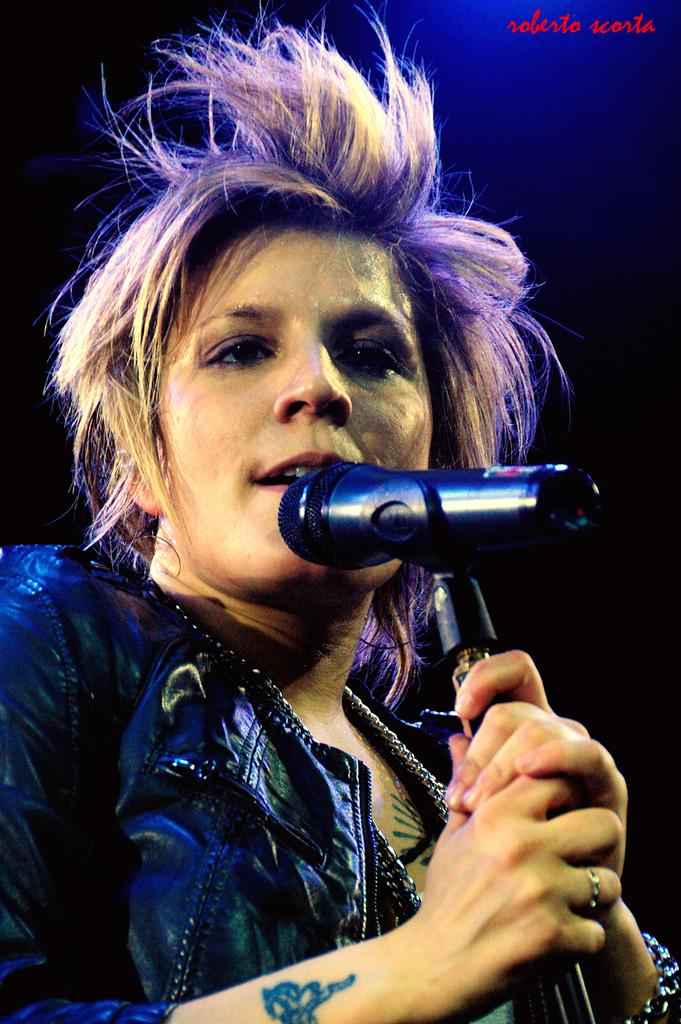Who is the main subject in the image? There is a woman in the image. What is the woman holding in the image? The woman is holding a microphone. What is the woman doing in the image? The woman is singing. Can you describe any jewelry the woman is wearing in the image? The woman has a ring on her right hand ring finger. Are there any visible body art or markings on the woman in the image? Yes, the woman has a tattoo on her hand. What color is the jacket the woman is wearing in the image? The woman is wearing a black color jacket. What type of vegetable is the woman using as a prop in the image? There is no vegetable present in the image; the woman is holding a microphone. What type of trousers is the woman wearing in the image? The provided facts do not mention the type of trousers the woman is wearing. 